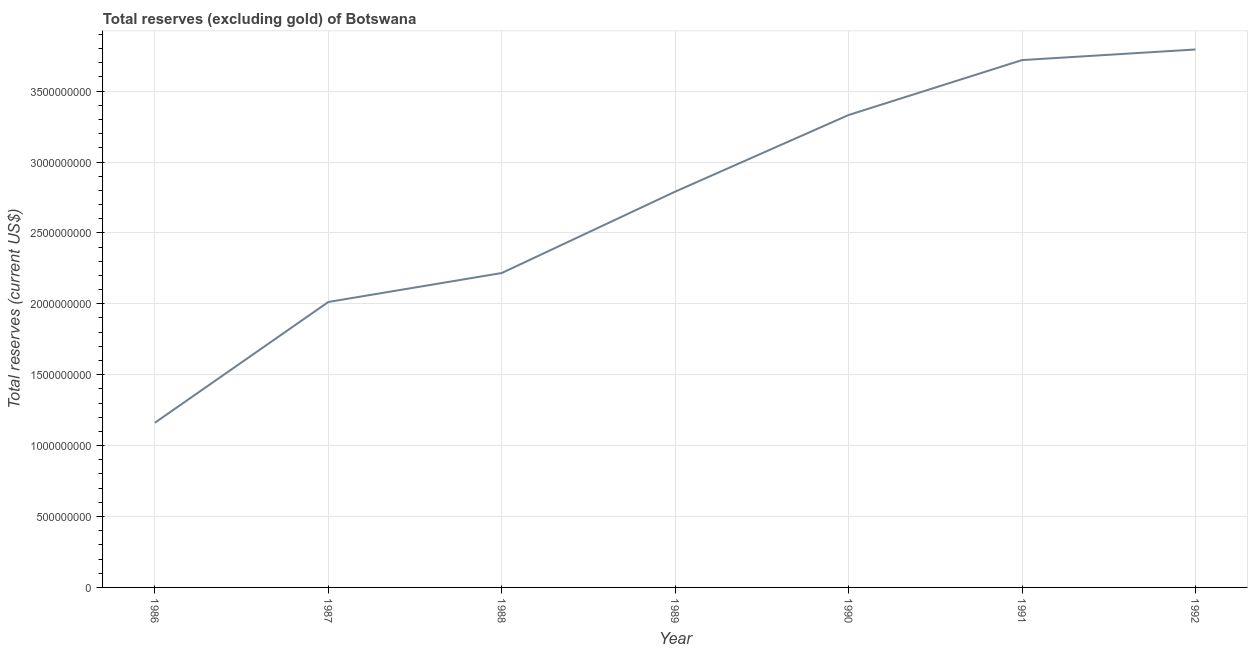What is the total reserves (excluding gold) in 1986?
Offer a very short reply. 1.16e+09. Across all years, what is the maximum total reserves (excluding gold)?
Offer a terse response. 3.79e+09. Across all years, what is the minimum total reserves (excluding gold)?
Provide a short and direct response. 1.16e+09. In which year was the total reserves (excluding gold) maximum?
Your answer should be compact. 1992. In which year was the total reserves (excluding gold) minimum?
Provide a short and direct response. 1986. What is the sum of the total reserves (excluding gold)?
Provide a short and direct response. 1.90e+1. What is the difference between the total reserves (excluding gold) in 1991 and 1992?
Your response must be concise. -7.48e+07. What is the average total reserves (excluding gold) per year?
Your response must be concise. 2.72e+09. What is the median total reserves (excluding gold)?
Your response must be concise. 2.79e+09. What is the ratio of the total reserves (excluding gold) in 1986 to that in 1988?
Give a very brief answer. 0.52. What is the difference between the highest and the second highest total reserves (excluding gold)?
Your answer should be compact. 7.48e+07. What is the difference between the highest and the lowest total reserves (excluding gold)?
Your response must be concise. 2.63e+09. How many lines are there?
Your answer should be very brief. 1. How many years are there in the graph?
Ensure brevity in your answer.  7. What is the difference between two consecutive major ticks on the Y-axis?
Make the answer very short. 5.00e+08. Are the values on the major ticks of Y-axis written in scientific E-notation?
Ensure brevity in your answer.  No. Does the graph contain any zero values?
Provide a short and direct response. No. Does the graph contain grids?
Keep it short and to the point. Yes. What is the title of the graph?
Give a very brief answer. Total reserves (excluding gold) of Botswana. What is the label or title of the Y-axis?
Your response must be concise. Total reserves (current US$). What is the Total reserves (current US$) in 1986?
Keep it short and to the point. 1.16e+09. What is the Total reserves (current US$) in 1987?
Give a very brief answer. 2.01e+09. What is the Total reserves (current US$) of 1988?
Your answer should be compact. 2.22e+09. What is the Total reserves (current US$) of 1989?
Your answer should be very brief. 2.79e+09. What is the Total reserves (current US$) of 1990?
Your response must be concise. 3.33e+09. What is the Total reserves (current US$) of 1991?
Offer a terse response. 3.72e+09. What is the Total reserves (current US$) of 1992?
Your answer should be compact. 3.79e+09. What is the difference between the Total reserves (current US$) in 1986 and 1987?
Provide a succinct answer. -8.51e+08. What is the difference between the Total reserves (current US$) in 1986 and 1988?
Offer a very short reply. -1.06e+09. What is the difference between the Total reserves (current US$) in 1986 and 1989?
Your answer should be very brief. -1.63e+09. What is the difference between the Total reserves (current US$) in 1986 and 1990?
Provide a succinct answer. -2.17e+09. What is the difference between the Total reserves (current US$) in 1986 and 1991?
Your answer should be compact. -2.56e+09. What is the difference between the Total reserves (current US$) in 1986 and 1992?
Keep it short and to the point. -2.63e+09. What is the difference between the Total reserves (current US$) in 1987 and 1988?
Your answer should be very brief. -2.04e+08. What is the difference between the Total reserves (current US$) in 1987 and 1989?
Your response must be concise. -7.78e+08. What is the difference between the Total reserves (current US$) in 1987 and 1990?
Give a very brief answer. -1.32e+09. What is the difference between the Total reserves (current US$) in 1987 and 1991?
Your answer should be very brief. -1.71e+09. What is the difference between the Total reserves (current US$) in 1987 and 1992?
Provide a succinct answer. -1.78e+09. What is the difference between the Total reserves (current US$) in 1988 and 1989?
Make the answer very short. -5.74e+08. What is the difference between the Total reserves (current US$) in 1988 and 1990?
Give a very brief answer. -1.11e+09. What is the difference between the Total reserves (current US$) in 1988 and 1991?
Provide a succinct answer. -1.50e+09. What is the difference between the Total reserves (current US$) in 1988 and 1992?
Your answer should be compact. -1.58e+09. What is the difference between the Total reserves (current US$) in 1989 and 1990?
Your answer should be compact. -5.40e+08. What is the difference between the Total reserves (current US$) in 1989 and 1991?
Your answer should be very brief. -9.28e+08. What is the difference between the Total reserves (current US$) in 1989 and 1992?
Your answer should be very brief. -1.00e+09. What is the difference between the Total reserves (current US$) in 1990 and 1991?
Provide a succinct answer. -3.87e+08. What is the difference between the Total reserves (current US$) in 1990 and 1992?
Your answer should be compact. -4.62e+08. What is the difference between the Total reserves (current US$) in 1991 and 1992?
Provide a short and direct response. -7.48e+07. What is the ratio of the Total reserves (current US$) in 1986 to that in 1987?
Keep it short and to the point. 0.58. What is the ratio of the Total reserves (current US$) in 1986 to that in 1988?
Your answer should be compact. 0.52. What is the ratio of the Total reserves (current US$) in 1986 to that in 1989?
Provide a short and direct response. 0.42. What is the ratio of the Total reserves (current US$) in 1986 to that in 1990?
Ensure brevity in your answer.  0.35. What is the ratio of the Total reserves (current US$) in 1986 to that in 1991?
Give a very brief answer. 0.31. What is the ratio of the Total reserves (current US$) in 1986 to that in 1992?
Make the answer very short. 0.31. What is the ratio of the Total reserves (current US$) in 1987 to that in 1988?
Keep it short and to the point. 0.91. What is the ratio of the Total reserves (current US$) in 1987 to that in 1989?
Offer a terse response. 0.72. What is the ratio of the Total reserves (current US$) in 1987 to that in 1990?
Offer a very short reply. 0.6. What is the ratio of the Total reserves (current US$) in 1987 to that in 1991?
Your answer should be compact. 0.54. What is the ratio of the Total reserves (current US$) in 1987 to that in 1992?
Offer a terse response. 0.53. What is the ratio of the Total reserves (current US$) in 1988 to that in 1989?
Offer a very short reply. 0.79. What is the ratio of the Total reserves (current US$) in 1988 to that in 1990?
Your answer should be very brief. 0.67. What is the ratio of the Total reserves (current US$) in 1988 to that in 1991?
Provide a succinct answer. 0.6. What is the ratio of the Total reserves (current US$) in 1988 to that in 1992?
Your response must be concise. 0.58. What is the ratio of the Total reserves (current US$) in 1989 to that in 1990?
Offer a terse response. 0.84. What is the ratio of the Total reserves (current US$) in 1989 to that in 1991?
Keep it short and to the point. 0.75. What is the ratio of the Total reserves (current US$) in 1989 to that in 1992?
Give a very brief answer. 0.74. What is the ratio of the Total reserves (current US$) in 1990 to that in 1991?
Make the answer very short. 0.9. What is the ratio of the Total reserves (current US$) in 1990 to that in 1992?
Offer a terse response. 0.88. What is the ratio of the Total reserves (current US$) in 1991 to that in 1992?
Your answer should be very brief. 0.98. 